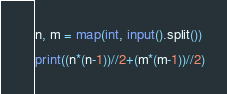Convert code to text. <code><loc_0><loc_0><loc_500><loc_500><_Python_>n, m = map(int, input().split())
print((n*(n-1))//2+(m*(m-1))//2)</code> 